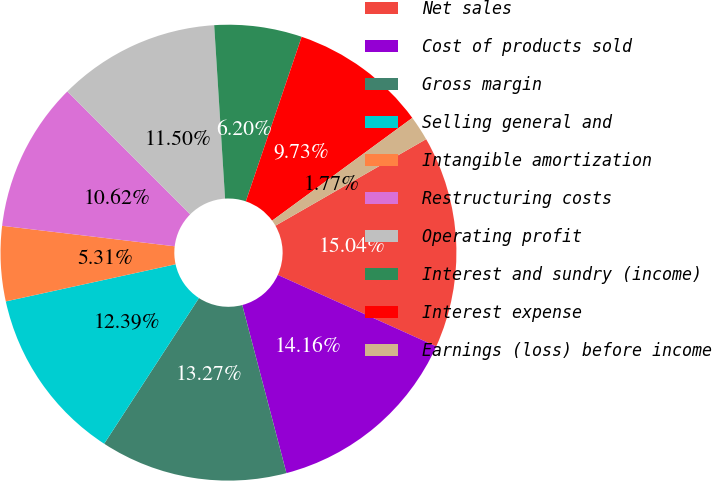Convert chart. <chart><loc_0><loc_0><loc_500><loc_500><pie_chart><fcel>Net sales<fcel>Cost of products sold<fcel>Gross margin<fcel>Selling general and<fcel>Intangible amortization<fcel>Restructuring costs<fcel>Operating profit<fcel>Interest and sundry (income)<fcel>Interest expense<fcel>Earnings (loss) before income<nl><fcel>15.04%<fcel>14.16%<fcel>13.27%<fcel>12.39%<fcel>5.31%<fcel>10.62%<fcel>11.5%<fcel>6.2%<fcel>9.73%<fcel>1.77%<nl></chart> 